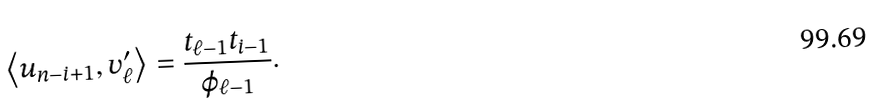<formula> <loc_0><loc_0><loc_500><loc_500>\left < u _ { n - i + 1 } , v _ { \ell } ^ { \prime } \right > = \frac { t _ { \ell - 1 } t _ { i - 1 } } { \varphi _ { \ell - 1 } } .</formula> 